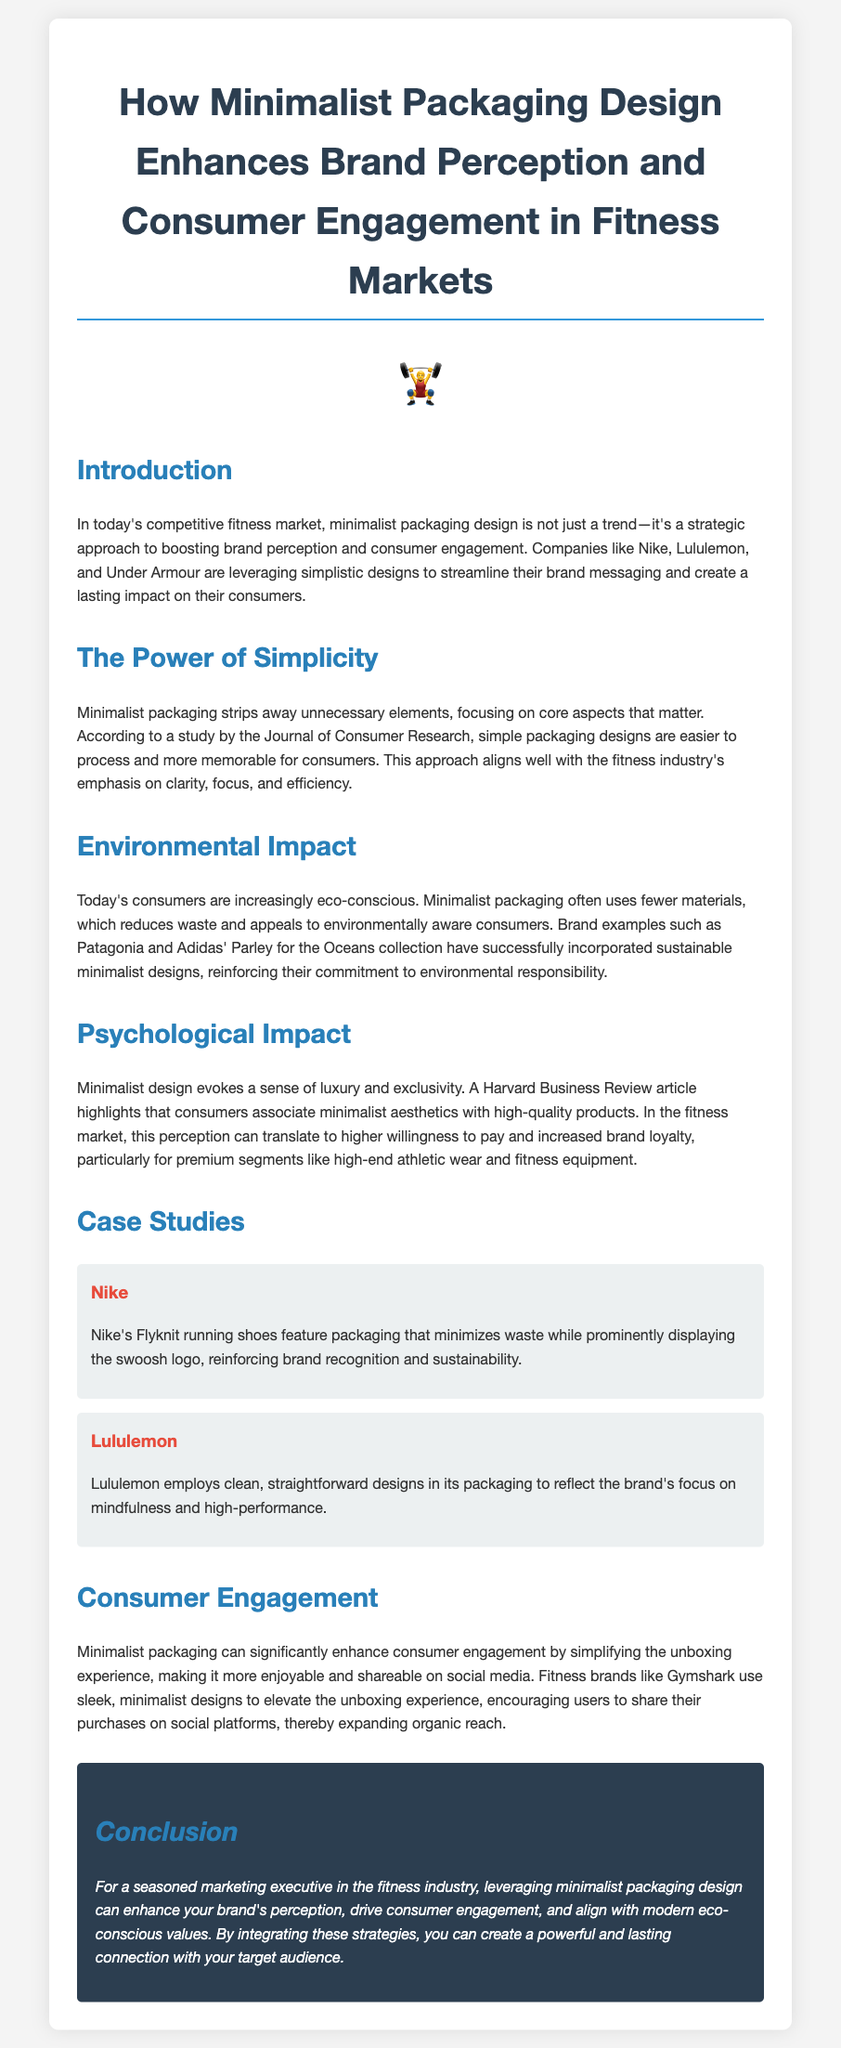What brands are mentioned for minimalist packaging? The brands mentioned in the document for minimalist packaging are Nike, Lululemon, and Under Armour.
Answer: Nike, Lululemon, Under Armour What is a key benefit of minimalist packaging according to the Journal of Consumer Research? The key benefit mentioned is that simple packaging designs are easier to process and more memorable for consumers.
Answer: Easier to process Which sustainable brand example is highlighted for its environmental commitment? The brand highlighted for its environmental commitment is Patagonia.
Answer: Patagonia What psychological attribute does minimalist design evoke? Minimalist design evokes a sense of luxury and exclusivity.
Answer: Luxury and exclusivity How does minimalist packaging affect consumer engagement according to the document? Minimalist packaging enhances consumer engagement by simplifying the unboxing experience.
Answer: Simplifying the unboxing experience What is the central theme of the conclusion? The central theme of the conclusion emphasizes enhancing brand perception and consumer engagement through minimalist packaging design.
Answer: Enhancing brand perception Which fitness brand is mentioned for using sleek packaging to utilize social sharing? The fitness brand mentioned for using sleek packaging is Gymshark.
Answer: Gymshark 